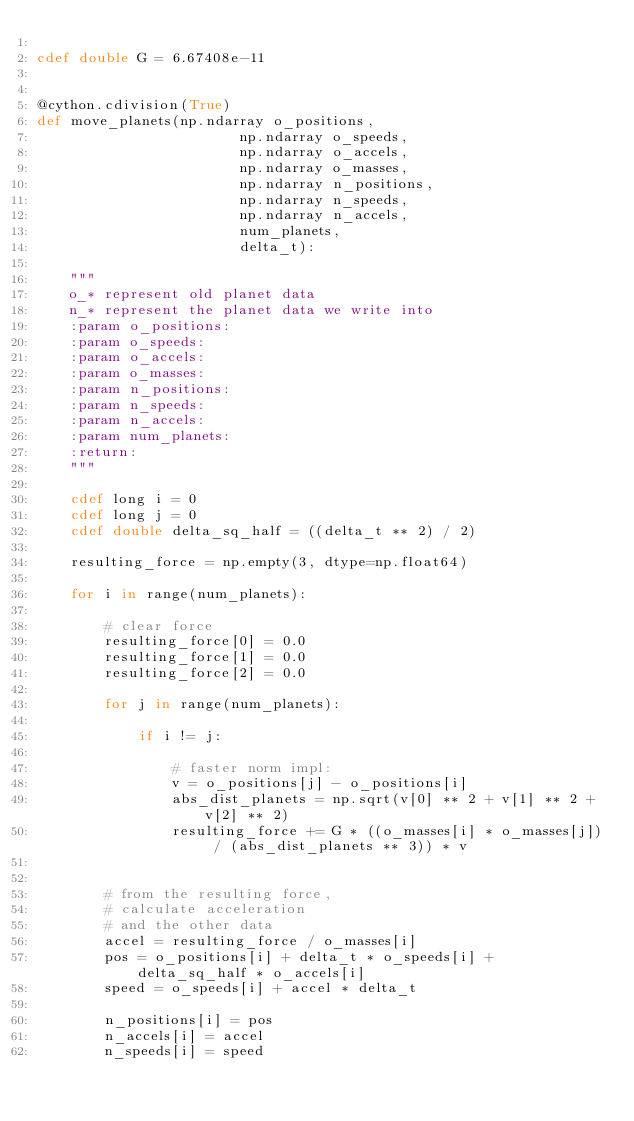Convert code to text. <code><loc_0><loc_0><loc_500><loc_500><_Cython_>
cdef double G = 6.67408e-11


@cython.cdivision(True)
def move_planets(np.ndarray o_positions,
                        np.ndarray o_speeds,
                        np.ndarray o_accels,
                        np.ndarray o_masses,
                        np.ndarray n_positions,
                        np.ndarray n_speeds,
                        np.ndarray n_accels,
                        num_planets,
                        delta_t):

    """
    o_* represent old planet data
    n_* represent the planet data we write into
    :param o_positions: 
    :param o_speeds: 
    :param o_accels: 
    :param o_masses: 
    :param n_positions: 
    :param n_speeds: 
    :param n_accels:
    :param num_planets:
    :return: 
    """

    cdef long i = 0
    cdef long j = 0
    cdef double delta_sq_half = ((delta_t ** 2) / 2)

    resulting_force = np.empty(3, dtype=np.float64)

    for i in range(num_planets):

        # clear force
        resulting_force[0] = 0.0
        resulting_force[1] = 0.0
        resulting_force[2] = 0.0

        for j in range(num_planets):

            if i != j:

                # faster norm impl:
                v = o_positions[j] - o_positions[i]
                abs_dist_planets = np.sqrt(v[0] ** 2 + v[1] ** 2 + v[2] ** 2)
                resulting_force += G * ((o_masses[i] * o_masses[j]) / (abs_dist_planets ** 3)) * v


        # from the resulting force,
        # calculate acceleration
        # and the other data
        accel = resulting_force / o_masses[i]
        pos = o_positions[i] + delta_t * o_speeds[i] + delta_sq_half * o_accels[i]
        speed = o_speeds[i] + accel * delta_t

        n_positions[i] = pos
        n_accels[i] = accel
        n_speeds[i] = speed










</code> 